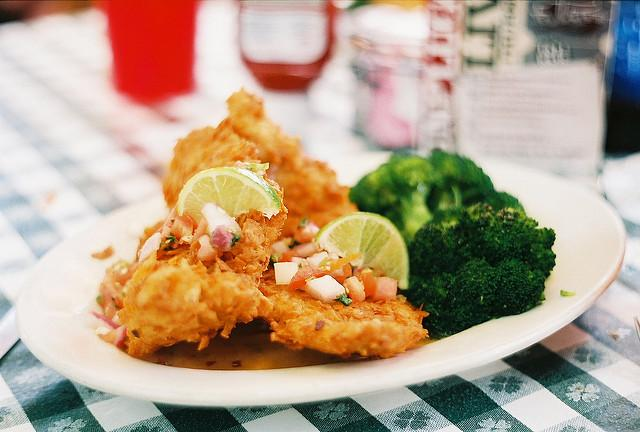What citrus fruit is atop the fried food? lime 